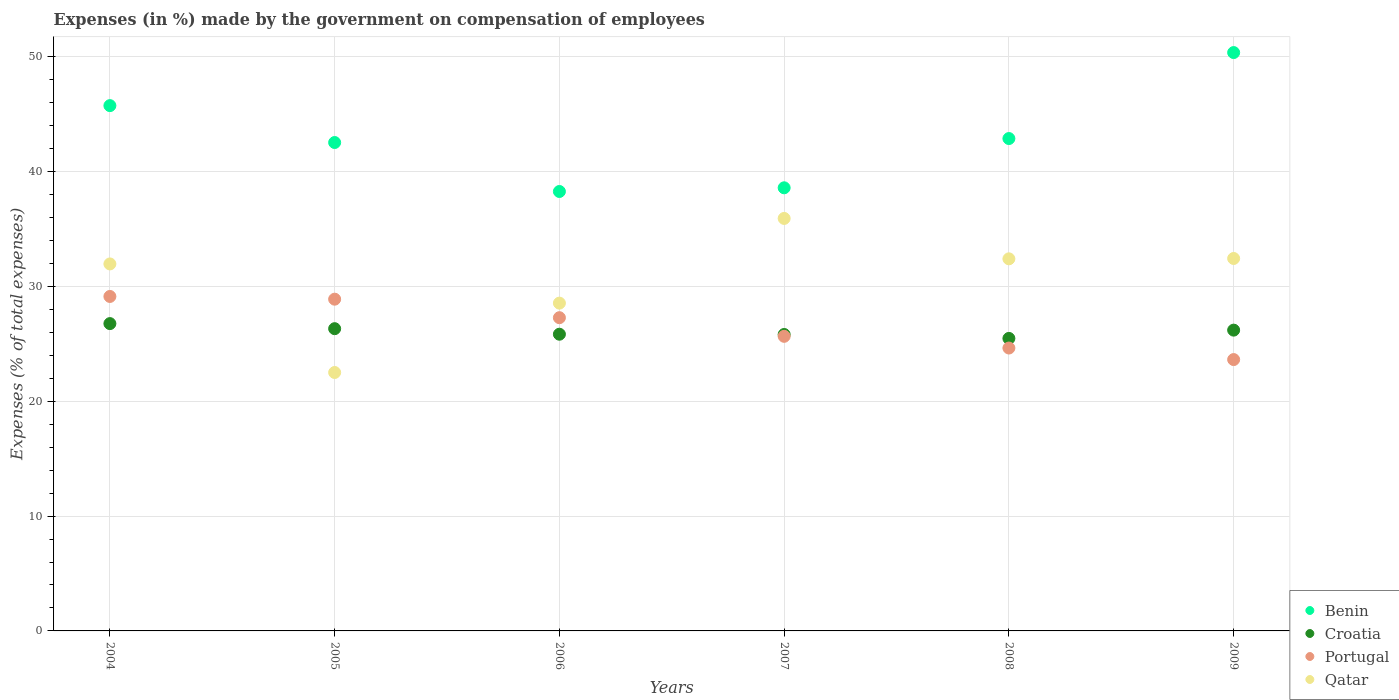What is the percentage of expenses made by the government on compensation of employees in Croatia in 2004?
Your answer should be compact. 26.76. Across all years, what is the maximum percentage of expenses made by the government on compensation of employees in Qatar?
Make the answer very short. 35.92. Across all years, what is the minimum percentage of expenses made by the government on compensation of employees in Croatia?
Give a very brief answer. 25.47. In which year was the percentage of expenses made by the government on compensation of employees in Croatia maximum?
Give a very brief answer. 2004. In which year was the percentage of expenses made by the government on compensation of employees in Benin minimum?
Give a very brief answer. 2006. What is the total percentage of expenses made by the government on compensation of employees in Benin in the graph?
Your answer should be very brief. 258.35. What is the difference between the percentage of expenses made by the government on compensation of employees in Qatar in 2004 and that in 2008?
Keep it short and to the point. -0.44. What is the difference between the percentage of expenses made by the government on compensation of employees in Portugal in 2007 and the percentage of expenses made by the government on compensation of employees in Qatar in 2008?
Offer a terse response. -6.75. What is the average percentage of expenses made by the government on compensation of employees in Croatia per year?
Make the answer very short. 26.06. In the year 2008, what is the difference between the percentage of expenses made by the government on compensation of employees in Benin and percentage of expenses made by the government on compensation of employees in Qatar?
Provide a short and direct response. 10.47. In how many years, is the percentage of expenses made by the government on compensation of employees in Qatar greater than 26 %?
Offer a very short reply. 5. What is the ratio of the percentage of expenses made by the government on compensation of employees in Benin in 2004 to that in 2007?
Provide a short and direct response. 1.19. Is the percentage of expenses made by the government on compensation of employees in Benin in 2004 less than that in 2006?
Your response must be concise. No. What is the difference between the highest and the second highest percentage of expenses made by the government on compensation of employees in Benin?
Keep it short and to the point. 4.62. What is the difference between the highest and the lowest percentage of expenses made by the government on compensation of employees in Qatar?
Offer a very short reply. 13.42. Is the sum of the percentage of expenses made by the government on compensation of employees in Portugal in 2005 and 2006 greater than the maximum percentage of expenses made by the government on compensation of employees in Croatia across all years?
Offer a terse response. Yes. Is it the case that in every year, the sum of the percentage of expenses made by the government on compensation of employees in Croatia and percentage of expenses made by the government on compensation of employees in Portugal  is greater than the sum of percentage of expenses made by the government on compensation of employees in Qatar and percentage of expenses made by the government on compensation of employees in Benin?
Offer a very short reply. No. Is it the case that in every year, the sum of the percentage of expenses made by the government on compensation of employees in Croatia and percentage of expenses made by the government on compensation of employees in Portugal  is greater than the percentage of expenses made by the government on compensation of employees in Benin?
Provide a succinct answer. No. Is the percentage of expenses made by the government on compensation of employees in Benin strictly greater than the percentage of expenses made by the government on compensation of employees in Croatia over the years?
Keep it short and to the point. Yes. Is the percentage of expenses made by the government on compensation of employees in Qatar strictly less than the percentage of expenses made by the government on compensation of employees in Portugal over the years?
Your answer should be very brief. No. Are the values on the major ticks of Y-axis written in scientific E-notation?
Provide a succinct answer. No. Does the graph contain any zero values?
Offer a terse response. No. Does the graph contain grids?
Give a very brief answer. Yes. Where does the legend appear in the graph?
Make the answer very short. Bottom right. What is the title of the graph?
Provide a succinct answer. Expenses (in %) made by the government on compensation of employees. What is the label or title of the Y-axis?
Offer a terse response. Expenses (% of total expenses). What is the Expenses (% of total expenses) of Benin in 2004?
Ensure brevity in your answer.  45.74. What is the Expenses (% of total expenses) of Croatia in 2004?
Provide a succinct answer. 26.76. What is the Expenses (% of total expenses) in Portugal in 2004?
Keep it short and to the point. 29.12. What is the Expenses (% of total expenses) in Qatar in 2004?
Offer a terse response. 31.96. What is the Expenses (% of total expenses) of Benin in 2005?
Your answer should be very brief. 42.53. What is the Expenses (% of total expenses) of Croatia in 2005?
Give a very brief answer. 26.32. What is the Expenses (% of total expenses) of Portugal in 2005?
Give a very brief answer. 28.89. What is the Expenses (% of total expenses) in Qatar in 2005?
Offer a terse response. 22.5. What is the Expenses (% of total expenses) of Benin in 2006?
Provide a short and direct response. 38.26. What is the Expenses (% of total expenses) of Croatia in 2006?
Your response must be concise. 25.84. What is the Expenses (% of total expenses) in Portugal in 2006?
Your answer should be very brief. 27.27. What is the Expenses (% of total expenses) of Qatar in 2006?
Ensure brevity in your answer.  28.54. What is the Expenses (% of total expenses) of Benin in 2007?
Your response must be concise. 38.59. What is the Expenses (% of total expenses) in Croatia in 2007?
Ensure brevity in your answer.  25.81. What is the Expenses (% of total expenses) in Portugal in 2007?
Keep it short and to the point. 25.65. What is the Expenses (% of total expenses) of Qatar in 2007?
Keep it short and to the point. 35.92. What is the Expenses (% of total expenses) of Benin in 2008?
Your response must be concise. 42.87. What is the Expenses (% of total expenses) of Croatia in 2008?
Offer a very short reply. 25.47. What is the Expenses (% of total expenses) in Portugal in 2008?
Give a very brief answer. 24.63. What is the Expenses (% of total expenses) of Qatar in 2008?
Your answer should be very brief. 32.4. What is the Expenses (% of total expenses) in Benin in 2009?
Your answer should be compact. 50.36. What is the Expenses (% of total expenses) of Croatia in 2009?
Make the answer very short. 26.19. What is the Expenses (% of total expenses) of Portugal in 2009?
Your response must be concise. 23.63. What is the Expenses (% of total expenses) in Qatar in 2009?
Offer a very short reply. 32.43. Across all years, what is the maximum Expenses (% of total expenses) of Benin?
Ensure brevity in your answer.  50.36. Across all years, what is the maximum Expenses (% of total expenses) of Croatia?
Provide a short and direct response. 26.76. Across all years, what is the maximum Expenses (% of total expenses) of Portugal?
Your answer should be very brief. 29.12. Across all years, what is the maximum Expenses (% of total expenses) in Qatar?
Ensure brevity in your answer.  35.92. Across all years, what is the minimum Expenses (% of total expenses) in Benin?
Offer a very short reply. 38.26. Across all years, what is the minimum Expenses (% of total expenses) in Croatia?
Provide a succinct answer. 25.47. Across all years, what is the minimum Expenses (% of total expenses) in Portugal?
Offer a terse response. 23.63. Across all years, what is the minimum Expenses (% of total expenses) in Qatar?
Your response must be concise. 22.5. What is the total Expenses (% of total expenses) in Benin in the graph?
Ensure brevity in your answer.  258.35. What is the total Expenses (% of total expenses) in Croatia in the graph?
Offer a very short reply. 156.39. What is the total Expenses (% of total expenses) in Portugal in the graph?
Provide a short and direct response. 159.2. What is the total Expenses (% of total expenses) of Qatar in the graph?
Your response must be concise. 183.75. What is the difference between the Expenses (% of total expenses) of Benin in 2004 and that in 2005?
Your answer should be compact. 3.21. What is the difference between the Expenses (% of total expenses) of Croatia in 2004 and that in 2005?
Give a very brief answer. 0.44. What is the difference between the Expenses (% of total expenses) in Portugal in 2004 and that in 2005?
Give a very brief answer. 0.24. What is the difference between the Expenses (% of total expenses) in Qatar in 2004 and that in 2005?
Provide a succinct answer. 9.45. What is the difference between the Expenses (% of total expenses) in Benin in 2004 and that in 2006?
Provide a short and direct response. 7.48. What is the difference between the Expenses (% of total expenses) of Croatia in 2004 and that in 2006?
Make the answer very short. 0.92. What is the difference between the Expenses (% of total expenses) of Portugal in 2004 and that in 2006?
Give a very brief answer. 1.85. What is the difference between the Expenses (% of total expenses) of Qatar in 2004 and that in 2006?
Your answer should be very brief. 3.41. What is the difference between the Expenses (% of total expenses) of Benin in 2004 and that in 2007?
Your answer should be compact. 7.16. What is the difference between the Expenses (% of total expenses) in Croatia in 2004 and that in 2007?
Your answer should be very brief. 0.95. What is the difference between the Expenses (% of total expenses) in Portugal in 2004 and that in 2007?
Make the answer very short. 3.47. What is the difference between the Expenses (% of total expenses) of Qatar in 2004 and that in 2007?
Provide a succinct answer. -3.96. What is the difference between the Expenses (% of total expenses) of Benin in 2004 and that in 2008?
Ensure brevity in your answer.  2.87. What is the difference between the Expenses (% of total expenses) of Croatia in 2004 and that in 2008?
Your answer should be compact. 1.29. What is the difference between the Expenses (% of total expenses) in Portugal in 2004 and that in 2008?
Provide a short and direct response. 4.49. What is the difference between the Expenses (% of total expenses) in Qatar in 2004 and that in 2008?
Make the answer very short. -0.44. What is the difference between the Expenses (% of total expenses) of Benin in 2004 and that in 2009?
Keep it short and to the point. -4.62. What is the difference between the Expenses (% of total expenses) of Croatia in 2004 and that in 2009?
Your answer should be very brief. 0.57. What is the difference between the Expenses (% of total expenses) of Portugal in 2004 and that in 2009?
Provide a succinct answer. 5.49. What is the difference between the Expenses (% of total expenses) of Qatar in 2004 and that in 2009?
Your answer should be very brief. -0.48. What is the difference between the Expenses (% of total expenses) in Benin in 2005 and that in 2006?
Your answer should be compact. 4.26. What is the difference between the Expenses (% of total expenses) of Croatia in 2005 and that in 2006?
Your answer should be compact. 0.48. What is the difference between the Expenses (% of total expenses) of Portugal in 2005 and that in 2006?
Provide a succinct answer. 1.61. What is the difference between the Expenses (% of total expenses) of Qatar in 2005 and that in 2006?
Keep it short and to the point. -6.04. What is the difference between the Expenses (% of total expenses) in Benin in 2005 and that in 2007?
Give a very brief answer. 3.94. What is the difference between the Expenses (% of total expenses) of Croatia in 2005 and that in 2007?
Your response must be concise. 0.51. What is the difference between the Expenses (% of total expenses) in Portugal in 2005 and that in 2007?
Provide a short and direct response. 3.23. What is the difference between the Expenses (% of total expenses) in Qatar in 2005 and that in 2007?
Ensure brevity in your answer.  -13.42. What is the difference between the Expenses (% of total expenses) of Benin in 2005 and that in 2008?
Provide a short and direct response. -0.35. What is the difference between the Expenses (% of total expenses) of Croatia in 2005 and that in 2008?
Provide a short and direct response. 0.85. What is the difference between the Expenses (% of total expenses) in Portugal in 2005 and that in 2008?
Keep it short and to the point. 4.25. What is the difference between the Expenses (% of total expenses) in Qatar in 2005 and that in 2008?
Give a very brief answer. -9.9. What is the difference between the Expenses (% of total expenses) of Benin in 2005 and that in 2009?
Make the answer very short. -7.83. What is the difference between the Expenses (% of total expenses) of Croatia in 2005 and that in 2009?
Give a very brief answer. 0.13. What is the difference between the Expenses (% of total expenses) in Portugal in 2005 and that in 2009?
Ensure brevity in your answer.  5.26. What is the difference between the Expenses (% of total expenses) of Qatar in 2005 and that in 2009?
Provide a short and direct response. -9.93. What is the difference between the Expenses (% of total expenses) in Benin in 2006 and that in 2007?
Offer a terse response. -0.32. What is the difference between the Expenses (% of total expenses) in Croatia in 2006 and that in 2007?
Give a very brief answer. 0.02. What is the difference between the Expenses (% of total expenses) of Portugal in 2006 and that in 2007?
Your answer should be very brief. 1.62. What is the difference between the Expenses (% of total expenses) of Qatar in 2006 and that in 2007?
Your response must be concise. -7.38. What is the difference between the Expenses (% of total expenses) of Benin in 2006 and that in 2008?
Offer a very short reply. -4.61. What is the difference between the Expenses (% of total expenses) in Croatia in 2006 and that in 2008?
Keep it short and to the point. 0.37. What is the difference between the Expenses (% of total expenses) in Portugal in 2006 and that in 2008?
Make the answer very short. 2.64. What is the difference between the Expenses (% of total expenses) in Qatar in 2006 and that in 2008?
Keep it short and to the point. -3.86. What is the difference between the Expenses (% of total expenses) of Benin in 2006 and that in 2009?
Offer a very short reply. -12.1. What is the difference between the Expenses (% of total expenses) in Croatia in 2006 and that in 2009?
Provide a short and direct response. -0.36. What is the difference between the Expenses (% of total expenses) in Portugal in 2006 and that in 2009?
Ensure brevity in your answer.  3.65. What is the difference between the Expenses (% of total expenses) of Qatar in 2006 and that in 2009?
Keep it short and to the point. -3.89. What is the difference between the Expenses (% of total expenses) of Benin in 2007 and that in 2008?
Keep it short and to the point. -4.29. What is the difference between the Expenses (% of total expenses) of Croatia in 2007 and that in 2008?
Keep it short and to the point. 0.34. What is the difference between the Expenses (% of total expenses) in Portugal in 2007 and that in 2008?
Offer a very short reply. 1.02. What is the difference between the Expenses (% of total expenses) in Qatar in 2007 and that in 2008?
Provide a succinct answer. 3.52. What is the difference between the Expenses (% of total expenses) of Benin in 2007 and that in 2009?
Keep it short and to the point. -11.78. What is the difference between the Expenses (% of total expenses) of Croatia in 2007 and that in 2009?
Offer a terse response. -0.38. What is the difference between the Expenses (% of total expenses) in Portugal in 2007 and that in 2009?
Your answer should be very brief. 2.02. What is the difference between the Expenses (% of total expenses) of Qatar in 2007 and that in 2009?
Provide a short and direct response. 3.49. What is the difference between the Expenses (% of total expenses) of Benin in 2008 and that in 2009?
Your answer should be very brief. -7.49. What is the difference between the Expenses (% of total expenses) in Croatia in 2008 and that in 2009?
Your answer should be very brief. -0.72. What is the difference between the Expenses (% of total expenses) of Portugal in 2008 and that in 2009?
Keep it short and to the point. 1. What is the difference between the Expenses (% of total expenses) in Qatar in 2008 and that in 2009?
Your answer should be compact. -0.03. What is the difference between the Expenses (% of total expenses) in Benin in 2004 and the Expenses (% of total expenses) in Croatia in 2005?
Ensure brevity in your answer.  19.42. What is the difference between the Expenses (% of total expenses) of Benin in 2004 and the Expenses (% of total expenses) of Portugal in 2005?
Make the answer very short. 16.85. What is the difference between the Expenses (% of total expenses) of Benin in 2004 and the Expenses (% of total expenses) of Qatar in 2005?
Keep it short and to the point. 23.24. What is the difference between the Expenses (% of total expenses) of Croatia in 2004 and the Expenses (% of total expenses) of Portugal in 2005?
Keep it short and to the point. -2.13. What is the difference between the Expenses (% of total expenses) in Croatia in 2004 and the Expenses (% of total expenses) in Qatar in 2005?
Your answer should be compact. 4.26. What is the difference between the Expenses (% of total expenses) of Portugal in 2004 and the Expenses (% of total expenses) of Qatar in 2005?
Your answer should be compact. 6.62. What is the difference between the Expenses (% of total expenses) of Benin in 2004 and the Expenses (% of total expenses) of Croatia in 2006?
Ensure brevity in your answer.  19.91. What is the difference between the Expenses (% of total expenses) of Benin in 2004 and the Expenses (% of total expenses) of Portugal in 2006?
Your response must be concise. 18.47. What is the difference between the Expenses (% of total expenses) in Benin in 2004 and the Expenses (% of total expenses) in Qatar in 2006?
Provide a succinct answer. 17.2. What is the difference between the Expenses (% of total expenses) in Croatia in 2004 and the Expenses (% of total expenses) in Portugal in 2006?
Keep it short and to the point. -0.51. What is the difference between the Expenses (% of total expenses) of Croatia in 2004 and the Expenses (% of total expenses) of Qatar in 2006?
Your response must be concise. -1.78. What is the difference between the Expenses (% of total expenses) of Portugal in 2004 and the Expenses (% of total expenses) of Qatar in 2006?
Offer a very short reply. 0.58. What is the difference between the Expenses (% of total expenses) in Benin in 2004 and the Expenses (% of total expenses) in Croatia in 2007?
Your answer should be compact. 19.93. What is the difference between the Expenses (% of total expenses) in Benin in 2004 and the Expenses (% of total expenses) in Portugal in 2007?
Make the answer very short. 20.09. What is the difference between the Expenses (% of total expenses) of Benin in 2004 and the Expenses (% of total expenses) of Qatar in 2007?
Keep it short and to the point. 9.82. What is the difference between the Expenses (% of total expenses) in Croatia in 2004 and the Expenses (% of total expenses) in Portugal in 2007?
Offer a very short reply. 1.11. What is the difference between the Expenses (% of total expenses) of Croatia in 2004 and the Expenses (% of total expenses) of Qatar in 2007?
Ensure brevity in your answer.  -9.16. What is the difference between the Expenses (% of total expenses) of Portugal in 2004 and the Expenses (% of total expenses) of Qatar in 2007?
Your answer should be compact. -6.79. What is the difference between the Expenses (% of total expenses) of Benin in 2004 and the Expenses (% of total expenses) of Croatia in 2008?
Offer a terse response. 20.27. What is the difference between the Expenses (% of total expenses) of Benin in 2004 and the Expenses (% of total expenses) of Portugal in 2008?
Provide a succinct answer. 21.11. What is the difference between the Expenses (% of total expenses) of Benin in 2004 and the Expenses (% of total expenses) of Qatar in 2008?
Give a very brief answer. 13.34. What is the difference between the Expenses (% of total expenses) in Croatia in 2004 and the Expenses (% of total expenses) in Portugal in 2008?
Your answer should be very brief. 2.13. What is the difference between the Expenses (% of total expenses) of Croatia in 2004 and the Expenses (% of total expenses) of Qatar in 2008?
Give a very brief answer. -5.64. What is the difference between the Expenses (% of total expenses) of Portugal in 2004 and the Expenses (% of total expenses) of Qatar in 2008?
Provide a succinct answer. -3.28. What is the difference between the Expenses (% of total expenses) in Benin in 2004 and the Expenses (% of total expenses) in Croatia in 2009?
Keep it short and to the point. 19.55. What is the difference between the Expenses (% of total expenses) of Benin in 2004 and the Expenses (% of total expenses) of Portugal in 2009?
Keep it short and to the point. 22.11. What is the difference between the Expenses (% of total expenses) in Benin in 2004 and the Expenses (% of total expenses) in Qatar in 2009?
Give a very brief answer. 13.31. What is the difference between the Expenses (% of total expenses) of Croatia in 2004 and the Expenses (% of total expenses) of Portugal in 2009?
Give a very brief answer. 3.13. What is the difference between the Expenses (% of total expenses) of Croatia in 2004 and the Expenses (% of total expenses) of Qatar in 2009?
Give a very brief answer. -5.67. What is the difference between the Expenses (% of total expenses) of Portugal in 2004 and the Expenses (% of total expenses) of Qatar in 2009?
Offer a very short reply. -3.31. What is the difference between the Expenses (% of total expenses) of Benin in 2005 and the Expenses (% of total expenses) of Croatia in 2006?
Provide a short and direct response. 16.69. What is the difference between the Expenses (% of total expenses) of Benin in 2005 and the Expenses (% of total expenses) of Portugal in 2006?
Keep it short and to the point. 15.25. What is the difference between the Expenses (% of total expenses) in Benin in 2005 and the Expenses (% of total expenses) in Qatar in 2006?
Your response must be concise. 13.98. What is the difference between the Expenses (% of total expenses) of Croatia in 2005 and the Expenses (% of total expenses) of Portugal in 2006?
Provide a short and direct response. -0.96. What is the difference between the Expenses (% of total expenses) in Croatia in 2005 and the Expenses (% of total expenses) in Qatar in 2006?
Keep it short and to the point. -2.22. What is the difference between the Expenses (% of total expenses) in Portugal in 2005 and the Expenses (% of total expenses) in Qatar in 2006?
Offer a terse response. 0.34. What is the difference between the Expenses (% of total expenses) in Benin in 2005 and the Expenses (% of total expenses) in Croatia in 2007?
Provide a succinct answer. 16.71. What is the difference between the Expenses (% of total expenses) of Benin in 2005 and the Expenses (% of total expenses) of Portugal in 2007?
Offer a very short reply. 16.88. What is the difference between the Expenses (% of total expenses) in Benin in 2005 and the Expenses (% of total expenses) in Qatar in 2007?
Keep it short and to the point. 6.61. What is the difference between the Expenses (% of total expenses) in Croatia in 2005 and the Expenses (% of total expenses) in Portugal in 2007?
Your answer should be compact. 0.67. What is the difference between the Expenses (% of total expenses) in Croatia in 2005 and the Expenses (% of total expenses) in Qatar in 2007?
Keep it short and to the point. -9.6. What is the difference between the Expenses (% of total expenses) of Portugal in 2005 and the Expenses (% of total expenses) of Qatar in 2007?
Your response must be concise. -7.03. What is the difference between the Expenses (% of total expenses) in Benin in 2005 and the Expenses (% of total expenses) in Croatia in 2008?
Offer a terse response. 17.06. What is the difference between the Expenses (% of total expenses) of Benin in 2005 and the Expenses (% of total expenses) of Portugal in 2008?
Provide a short and direct response. 17.89. What is the difference between the Expenses (% of total expenses) of Benin in 2005 and the Expenses (% of total expenses) of Qatar in 2008?
Your answer should be compact. 10.13. What is the difference between the Expenses (% of total expenses) of Croatia in 2005 and the Expenses (% of total expenses) of Portugal in 2008?
Make the answer very short. 1.69. What is the difference between the Expenses (% of total expenses) of Croatia in 2005 and the Expenses (% of total expenses) of Qatar in 2008?
Give a very brief answer. -6.08. What is the difference between the Expenses (% of total expenses) of Portugal in 2005 and the Expenses (% of total expenses) of Qatar in 2008?
Keep it short and to the point. -3.51. What is the difference between the Expenses (% of total expenses) in Benin in 2005 and the Expenses (% of total expenses) in Croatia in 2009?
Offer a very short reply. 16.34. What is the difference between the Expenses (% of total expenses) in Benin in 2005 and the Expenses (% of total expenses) in Portugal in 2009?
Give a very brief answer. 18.9. What is the difference between the Expenses (% of total expenses) in Benin in 2005 and the Expenses (% of total expenses) in Qatar in 2009?
Offer a terse response. 10.1. What is the difference between the Expenses (% of total expenses) of Croatia in 2005 and the Expenses (% of total expenses) of Portugal in 2009?
Your answer should be compact. 2.69. What is the difference between the Expenses (% of total expenses) of Croatia in 2005 and the Expenses (% of total expenses) of Qatar in 2009?
Keep it short and to the point. -6.11. What is the difference between the Expenses (% of total expenses) of Portugal in 2005 and the Expenses (% of total expenses) of Qatar in 2009?
Provide a succinct answer. -3.54. What is the difference between the Expenses (% of total expenses) of Benin in 2006 and the Expenses (% of total expenses) of Croatia in 2007?
Provide a short and direct response. 12.45. What is the difference between the Expenses (% of total expenses) in Benin in 2006 and the Expenses (% of total expenses) in Portugal in 2007?
Offer a terse response. 12.61. What is the difference between the Expenses (% of total expenses) in Benin in 2006 and the Expenses (% of total expenses) in Qatar in 2007?
Provide a short and direct response. 2.35. What is the difference between the Expenses (% of total expenses) in Croatia in 2006 and the Expenses (% of total expenses) in Portugal in 2007?
Ensure brevity in your answer.  0.18. What is the difference between the Expenses (% of total expenses) in Croatia in 2006 and the Expenses (% of total expenses) in Qatar in 2007?
Make the answer very short. -10.08. What is the difference between the Expenses (% of total expenses) of Portugal in 2006 and the Expenses (% of total expenses) of Qatar in 2007?
Give a very brief answer. -8.64. What is the difference between the Expenses (% of total expenses) of Benin in 2006 and the Expenses (% of total expenses) of Croatia in 2008?
Offer a terse response. 12.79. What is the difference between the Expenses (% of total expenses) in Benin in 2006 and the Expenses (% of total expenses) in Portugal in 2008?
Make the answer very short. 13.63. What is the difference between the Expenses (% of total expenses) of Benin in 2006 and the Expenses (% of total expenses) of Qatar in 2008?
Your answer should be compact. 5.86. What is the difference between the Expenses (% of total expenses) in Croatia in 2006 and the Expenses (% of total expenses) in Portugal in 2008?
Keep it short and to the point. 1.2. What is the difference between the Expenses (% of total expenses) in Croatia in 2006 and the Expenses (% of total expenses) in Qatar in 2008?
Offer a very short reply. -6.56. What is the difference between the Expenses (% of total expenses) of Portugal in 2006 and the Expenses (% of total expenses) of Qatar in 2008?
Offer a terse response. -5.13. What is the difference between the Expenses (% of total expenses) of Benin in 2006 and the Expenses (% of total expenses) of Croatia in 2009?
Offer a terse response. 12.07. What is the difference between the Expenses (% of total expenses) in Benin in 2006 and the Expenses (% of total expenses) in Portugal in 2009?
Your answer should be compact. 14.64. What is the difference between the Expenses (% of total expenses) in Benin in 2006 and the Expenses (% of total expenses) in Qatar in 2009?
Give a very brief answer. 5.83. What is the difference between the Expenses (% of total expenses) in Croatia in 2006 and the Expenses (% of total expenses) in Portugal in 2009?
Your answer should be very brief. 2.21. What is the difference between the Expenses (% of total expenses) of Croatia in 2006 and the Expenses (% of total expenses) of Qatar in 2009?
Give a very brief answer. -6.6. What is the difference between the Expenses (% of total expenses) in Portugal in 2006 and the Expenses (% of total expenses) in Qatar in 2009?
Keep it short and to the point. -5.16. What is the difference between the Expenses (% of total expenses) in Benin in 2007 and the Expenses (% of total expenses) in Croatia in 2008?
Your answer should be compact. 13.11. What is the difference between the Expenses (% of total expenses) in Benin in 2007 and the Expenses (% of total expenses) in Portugal in 2008?
Provide a succinct answer. 13.95. What is the difference between the Expenses (% of total expenses) in Benin in 2007 and the Expenses (% of total expenses) in Qatar in 2008?
Provide a short and direct response. 6.18. What is the difference between the Expenses (% of total expenses) in Croatia in 2007 and the Expenses (% of total expenses) in Portugal in 2008?
Offer a very short reply. 1.18. What is the difference between the Expenses (% of total expenses) in Croatia in 2007 and the Expenses (% of total expenses) in Qatar in 2008?
Your answer should be very brief. -6.59. What is the difference between the Expenses (% of total expenses) in Portugal in 2007 and the Expenses (% of total expenses) in Qatar in 2008?
Ensure brevity in your answer.  -6.75. What is the difference between the Expenses (% of total expenses) of Benin in 2007 and the Expenses (% of total expenses) of Croatia in 2009?
Your answer should be very brief. 12.39. What is the difference between the Expenses (% of total expenses) of Benin in 2007 and the Expenses (% of total expenses) of Portugal in 2009?
Your response must be concise. 14.96. What is the difference between the Expenses (% of total expenses) in Benin in 2007 and the Expenses (% of total expenses) in Qatar in 2009?
Provide a succinct answer. 6.15. What is the difference between the Expenses (% of total expenses) of Croatia in 2007 and the Expenses (% of total expenses) of Portugal in 2009?
Provide a succinct answer. 2.18. What is the difference between the Expenses (% of total expenses) in Croatia in 2007 and the Expenses (% of total expenses) in Qatar in 2009?
Keep it short and to the point. -6.62. What is the difference between the Expenses (% of total expenses) of Portugal in 2007 and the Expenses (% of total expenses) of Qatar in 2009?
Give a very brief answer. -6.78. What is the difference between the Expenses (% of total expenses) in Benin in 2008 and the Expenses (% of total expenses) in Croatia in 2009?
Provide a short and direct response. 16.68. What is the difference between the Expenses (% of total expenses) of Benin in 2008 and the Expenses (% of total expenses) of Portugal in 2009?
Keep it short and to the point. 19.25. What is the difference between the Expenses (% of total expenses) in Benin in 2008 and the Expenses (% of total expenses) in Qatar in 2009?
Offer a very short reply. 10.44. What is the difference between the Expenses (% of total expenses) of Croatia in 2008 and the Expenses (% of total expenses) of Portugal in 2009?
Make the answer very short. 1.84. What is the difference between the Expenses (% of total expenses) of Croatia in 2008 and the Expenses (% of total expenses) of Qatar in 2009?
Give a very brief answer. -6.96. What is the difference between the Expenses (% of total expenses) of Portugal in 2008 and the Expenses (% of total expenses) of Qatar in 2009?
Make the answer very short. -7.8. What is the average Expenses (% of total expenses) of Benin per year?
Give a very brief answer. 43.06. What is the average Expenses (% of total expenses) in Croatia per year?
Your answer should be compact. 26.06. What is the average Expenses (% of total expenses) in Portugal per year?
Give a very brief answer. 26.53. What is the average Expenses (% of total expenses) in Qatar per year?
Your answer should be very brief. 30.63. In the year 2004, what is the difference between the Expenses (% of total expenses) in Benin and Expenses (% of total expenses) in Croatia?
Offer a very short reply. 18.98. In the year 2004, what is the difference between the Expenses (% of total expenses) of Benin and Expenses (% of total expenses) of Portugal?
Keep it short and to the point. 16.62. In the year 2004, what is the difference between the Expenses (% of total expenses) of Benin and Expenses (% of total expenses) of Qatar?
Your answer should be very brief. 13.78. In the year 2004, what is the difference between the Expenses (% of total expenses) in Croatia and Expenses (% of total expenses) in Portugal?
Offer a terse response. -2.36. In the year 2004, what is the difference between the Expenses (% of total expenses) of Croatia and Expenses (% of total expenses) of Qatar?
Your response must be concise. -5.2. In the year 2004, what is the difference between the Expenses (% of total expenses) in Portugal and Expenses (% of total expenses) in Qatar?
Offer a terse response. -2.83. In the year 2005, what is the difference between the Expenses (% of total expenses) of Benin and Expenses (% of total expenses) of Croatia?
Provide a succinct answer. 16.21. In the year 2005, what is the difference between the Expenses (% of total expenses) in Benin and Expenses (% of total expenses) in Portugal?
Give a very brief answer. 13.64. In the year 2005, what is the difference between the Expenses (% of total expenses) in Benin and Expenses (% of total expenses) in Qatar?
Provide a succinct answer. 20.02. In the year 2005, what is the difference between the Expenses (% of total expenses) in Croatia and Expenses (% of total expenses) in Portugal?
Your answer should be compact. -2.57. In the year 2005, what is the difference between the Expenses (% of total expenses) in Croatia and Expenses (% of total expenses) in Qatar?
Offer a very short reply. 3.82. In the year 2005, what is the difference between the Expenses (% of total expenses) of Portugal and Expenses (% of total expenses) of Qatar?
Offer a very short reply. 6.38. In the year 2006, what is the difference between the Expenses (% of total expenses) of Benin and Expenses (% of total expenses) of Croatia?
Provide a succinct answer. 12.43. In the year 2006, what is the difference between the Expenses (% of total expenses) in Benin and Expenses (% of total expenses) in Portugal?
Provide a short and direct response. 10.99. In the year 2006, what is the difference between the Expenses (% of total expenses) in Benin and Expenses (% of total expenses) in Qatar?
Make the answer very short. 9.72. In the year 2006, what is the difference between the Expenses (% of total expenses) in Croatia and Expenses (% of total expenses) in Portugal?
Your response must be concise. -1.44. In the year 2006, what is the difference between the Expenses (% of total expenses) in Croatia and Expenses (% of total expenses) in Qatar?
Offer a very short reply. -2.71. In the year 2006, what is the difference between the Expenses (% of total expenses) in Portugal and Expenses (% of total expenses) in Qatar?
Provide a short and direct response. -1.27. In the year 2007, what is the difference between the Expenses (% of total expenses) of Benin and Expenses (% of total expenses) of Croatia?
Keep it short and to the point. 12.77. In the year 2007, what is the difference between the Expenses (% of total expenses) in Benin and Expenses (% of total expenses) in Portugal?
Your answer should be compact. 12.93. In the year 2007, what is the difference between the Expenses (% of total expenses) of Benin and Expenses (% of total expenses) of Qatar?
Offer a very short reply. 2.67. In the year 2007, what is the difference between the Expenses (% of total expenses) in Croatia and Expenses (% of total expenses) in Portugal?
Offer a terse response. 0.16. In the year 2007, what is the difference between the Expenses (% of total expenses) in Croatia and Expenses (% of total expenses) in Qatar?
Ensure brevity in your answer.  -10.11. In the year 2007, what is the difference between the Expenses (% of total expenses) in Portugal and Expenses (% of total expenses) in Qatar?
Keep it short and to the point. -10.27. In the year 2008, what is the difference between the Expenses (% of total expenses) in Benin and Expenses (% of total expenses) in Croatia?
Keep it short and to the point. 17.4. In the year 2008, what is the difference between the Expenses (% of total expenses) of Benin and Expenses (% of total expenses) of Portugal?
Your response must be concise. 18.24. In the year 2008, what is the difference between the Expenses (% of total expenses) of Benin and Expenses (% of total expenses) of Qatar?
Offer a terse response. 10.47. In the year 2008, what is the difference between the Expenses (% of total expenses) in Croatia and Expenses (% of total expenses) in Portugal?
Your answer should be very brief. 0.84. In the year 2008, what is the difference between the Expenses (% of total expenses) of Croatia and Expenses (% of total expenses) of Qatar?
Make the answer very short. -6.93. In the year 2008, what is the difference between the Expenses (% of total expenses) of Portugal and Expenses (% of total expenses) of Qatar?
Offer a very short reply. -7.77. In the year 2009, what is the difference between the Expenses (% of total expenses) in Benin and Expenses (% of total expenses) in Croatia?
Your answer should be very brief. 24.17. In the year 2009, what is the difference between the Expenses (% of total expenses) of Benin and Expenses (% of total expenses) of Portugal?
Make the answer very short. 26.73. In the year 2009, what is the difference between the Expenses (% of total expenses) in Benin and Expenses (% of total expenses) in Qatar?
Provide a short and direct response. 17.93. In the year 2009, what is the difference between the Expenses (% of total expenses) in Croatia and Expenses (% of total expenses) in Portugal?
Your answer should be compact. 2.56. In the year 2009, what is the difference between the Expenses (% of total expenses) in Croatia and Expenses (% of total expenses) in Qatar?
Make the answer very short. -6.24. In the year 2009, what is the difference between the Expenses (% of total expenses) of Portugal and Expenses (% of total expenses) of Qatar?
Make the answer very short. -8.8. What is the ratio of the Expenses (% of total expenses) in Benin in 2004 to that in 2005?
Provide a short and direct response. 1.08. What is the ratio of the Expenses (% of total expenses) in Croatia in 2004 to that in 2005?
Provide a short and direct response. 1.02. What is the ratio of the Expenses (% of total expenses) of Portugal in 2004 to that in 2005?
Ensure brevity in your answer.  1.01. What is the ratio of the Expenses (% of total expenses) in Qatar in 2004 to that in 2005?
Make the answer very short. 1.42. What is the ratio of the Expenses (% of total expenses) in Benin in 2004 to that in 2006?
Provide a succinct answer. 1.2. What is the ratio of the Expenses (% of total expenses) of Croatia in 2004 to that in 2006?
Your answer should be very brief. 1.04. What is the ratio of the Expenses (% of total expenses) of Portugal in 2004 to that in 2006?
Ensure brevity in your answer.  1.07. What is the ratio of the Expenses (% of total expenses) in Qatar in 2004 to that in 2006?
Your response must be concise. 1.12. What is the ratio of the Expenses (% of total expenses) in Benin in 2004 to that in 2007?
Provide a succinct answer. 1.19. What is the ratio of the Expenses (% of total expenses) of Croatia in 2004 to that in 2007?
Your answer should be very brief. 1.04. What is the ratio of the Expenses (% of total expenses) in Portugal in 2004 to that in 2007?
Give a very brief answer. 1.14. What is the ratio of the Expenses (% of total expenses) in Qatar in 2004 to that in 2007?
Offer a very short reply. 0.89. What is the ratio of the Expenses (% of total expenses) in Benin in 2004 to that in 2008?
Provide a succinct answer. 1.07. What is the ratio of the Expenses (% of total expenses) of Croatia in 2004 to that in 2008?
Offer a very short reply. 1.05. What is the ratio of the Expenses (% of total expenses) in Portugal in 2004 to that in 2008?
Your response must be concise. 1.18. What is the ratio of the Expenses (% of total expenses) in Qatar in 2004 to that in 2008?
Your answer should be compact. 0.99. What is the ratio of the Expenses (% of total expenses) in Benin in 2004 to that in 2009?
Your response must be concise. 0.91. What is the ratio of the Expenses (% of total expenses) of Croatia in 2004 to that in 2009?
Provide a short and direct response. 1.02. What is the ratio of the Expenses (% of total expenses) of Portugal in 2004 to that in 2009?
Your answer should be compact. 1.23. What is the ratio of the Expenses (% of total expenses) of Benin in 2005 to that in 2006?
Provide a succinct answer. 1.11. What is the ratio of the Expenses (% of total expenses) in Croatia in 2005 to that in 2006?
Your answer should be compact. 1.02. What is the ratio of the Expenses (% of total expenses) of Portugal in 2005 to that in 2006?
Ensure brevity in your answer.  1.06. What is the ratio of the Expenses (% of total expenses) in Qatar in 2005 to that in 2006?
Offer a very short reply. 0.79. What is the ratio of the Expenses (% of total expenses) of Benin in 2005 to that in 2007?
Offer a terse response. 1.1. What is the ratio of the Expenses (% of total expenses) of Croatia in 2005 to that in 2007?
Offer a very short reply. 1.02. What is the ratio of the Expenses (% of total expenses) of Portugal in 2005 to that in 2007?
Offer a very short reply. 1.13. What is the ratio of the Expenses (% of total expenses) in Qatar in 2005 to that in 2007?
Ensure brevity in your answer.  0.63. What is the ratio of the Expenses (% of total expenses) of Portugal in 2005 to that in 2008?
Offer a terse response. 1.17. What is the ratio of the Expenses (% of total expenses) of Qatar in 2005 to that in 2008?
Your response must be concise. 0.69. What is the ratio of the Expenses (% of total expenses) of Benin in 2005 to that in 2009?
Your answer should be very brief. 0.84. What is the ratio of the Expenses (% of total expenses) of Croatia in 2005 to that in 2009?
Your answer should be compact. 1. What is the ratio of the Expenses (% of total expenses) of Portugal in 2005 to that in 2009?
Offer a terse response. 1.22. What is the ratio of the Expenses (% of total expenses) of Qatar in 2005 to that in 2009?
Provide a short and direct response. 0.69. What is the ratio of the Expenses (% of total expenses) in Benin in 2006 to that in 2007?
Offer a terse response. 0.99. What is the ratio of the Expenses (% of total expenses) of Croatia in 2006 to that in 2007?
Provide a short and direct response. 1. What is the ratio of the Expenses (% of total expenses) of Portugal in 2006 to that in 2007?
Provide a succinct answer. 1.06. What is the ratio of the Expenses (% of total expenses) of Qatar in 2006 to that in 2007?
Make the answer very short. 0.79. What is the ratio of the Expenses (% of total expenses) of Benin in 2006 to that in 2008?
Your response must be concise. 0.89. What is the ratio of the Expenses (% of total expenses) in Croatia in 2006 to that in 2008?
Your answer should be compact. 1.01. What is the ratio of the Expenses (% of total expenses) in Portugal in 2006 to that in 2008?
Provide a short and direct response. 1.11. What is the ratio of the Expenses (% of total expenses) of Qatar in 2006 to that in 2008?
Keep it short and to the point. 0.88. What is the ratio of the Expenses (% of total expenses) of Benin in 2006 to that in 2009?
Your answer should be very brief. 0.76. What is the ratio of the Expenses (% of total expenses) of Croatia in 2006 to that in 2009?
Make the answer very short. 0.99. What is the ratio of the Expenses (% of total expenses) of Portugal in 2006 to that in 2009?
Provide a succinct answer. 1.15. What is the ratio of the Expenses (% of total expenses) in Qatar in 2006 to that in 2009?
Your answer should be very brief. 0.88. What is the ratio of the Expenses (% of total expenses) of Benin in 2007 to that in 2008?
Offer a terse response. 0.9. What is the ratio of the Expenses (% of total expenses) of Croatia in 2007 to that in 2008?
Provide a short and direct response. 1.01. What is the ratio of the Expenses (% of total expenses) in Portugal in 2007 to that in 2008?
Offer a very short reply. 1.04. What is the ratio of the Expenses (% of total expenses) in Qatar in 2007 to that in 2008?
Offer a terse response. 1.11. What is the ratio of the Expenses (% of total expenses) of Benin in 2007 to that in 2009?
Offer a very short reply. 0.77. What is the ratio of the Expenses (% of total expenses) in Croatia in 2007 to that in 2009?
Your answer should be compact. 0.99. What is the ratio of the Expenses (% of total expenses) in Portugal in 2007 to that in 2009?
Provide a short and direct response. 1.09. What is the ratio of the Expenses (% of total expenses) of Qatar in 2007 to that in 2009?
Provide a succinct answer. 1.11. What is the ratio of the Expenses (% of total expenses) in Benin in 2008 to that in 2009?
Make the answer very short. 0.85. What is the ratio of the Expenses (% of total expenses) of Croatia in 2008 to that in 2009?
Offer a very short reply. 0.97. What is the ratio of the Expenses (% of total expenses) of Portugal in 2008 to that in 2009?
Keep it short and to the point. 1.04. What is the difference between the highest and the second highest Expenses (% of total expenses) in Benin?
Keep it short and to the point. 4.62. What is the difference between the highest and the second highest Expenses (% of total expenses) of Croatia?
Give a very brief answer. 0.44. What is the difference between the highest and the second highest Expenses (% of total expenses) in Portugal?
Your answer should be very brief. 0.24. What is the difference between the highest and the second highest Expenses (% of total expenses) of Qatar?
Your answer should be compact. 3.49. What is the difference between the highest and the lowest Expenses (% of total expenses) in Benin?
Offer a terse response. 12.1. What is the difference between the highest and the lowest Expenses (% of total expenses) in Croatia?
Provide a short and direct response. 1.29. What is the difference between the highest and the lowest Expenses (% of total expenses) of Portugal?
Your answer should be very brief. 5.49. What is the difference between the highest and the lowest Expenses (% of total expenses) in Qatar?
Your answer should be very brief. 13.42. 